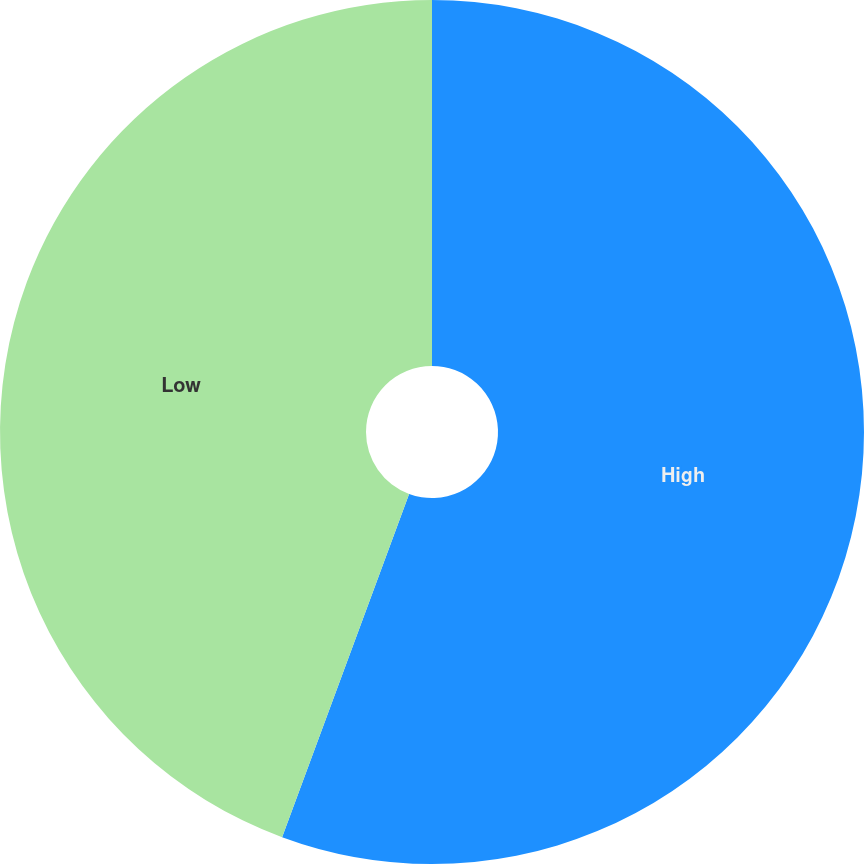<chart> <loc_0><loc_0><loc_500><loc_500><pie_chart><fcel>High<fcel>Low<nl><fcel>55.64%<fcel>44.36%<nl></chart> 